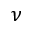<formula> <loc_0><loc_0><loc_500><loc_500>\nu</formula> 